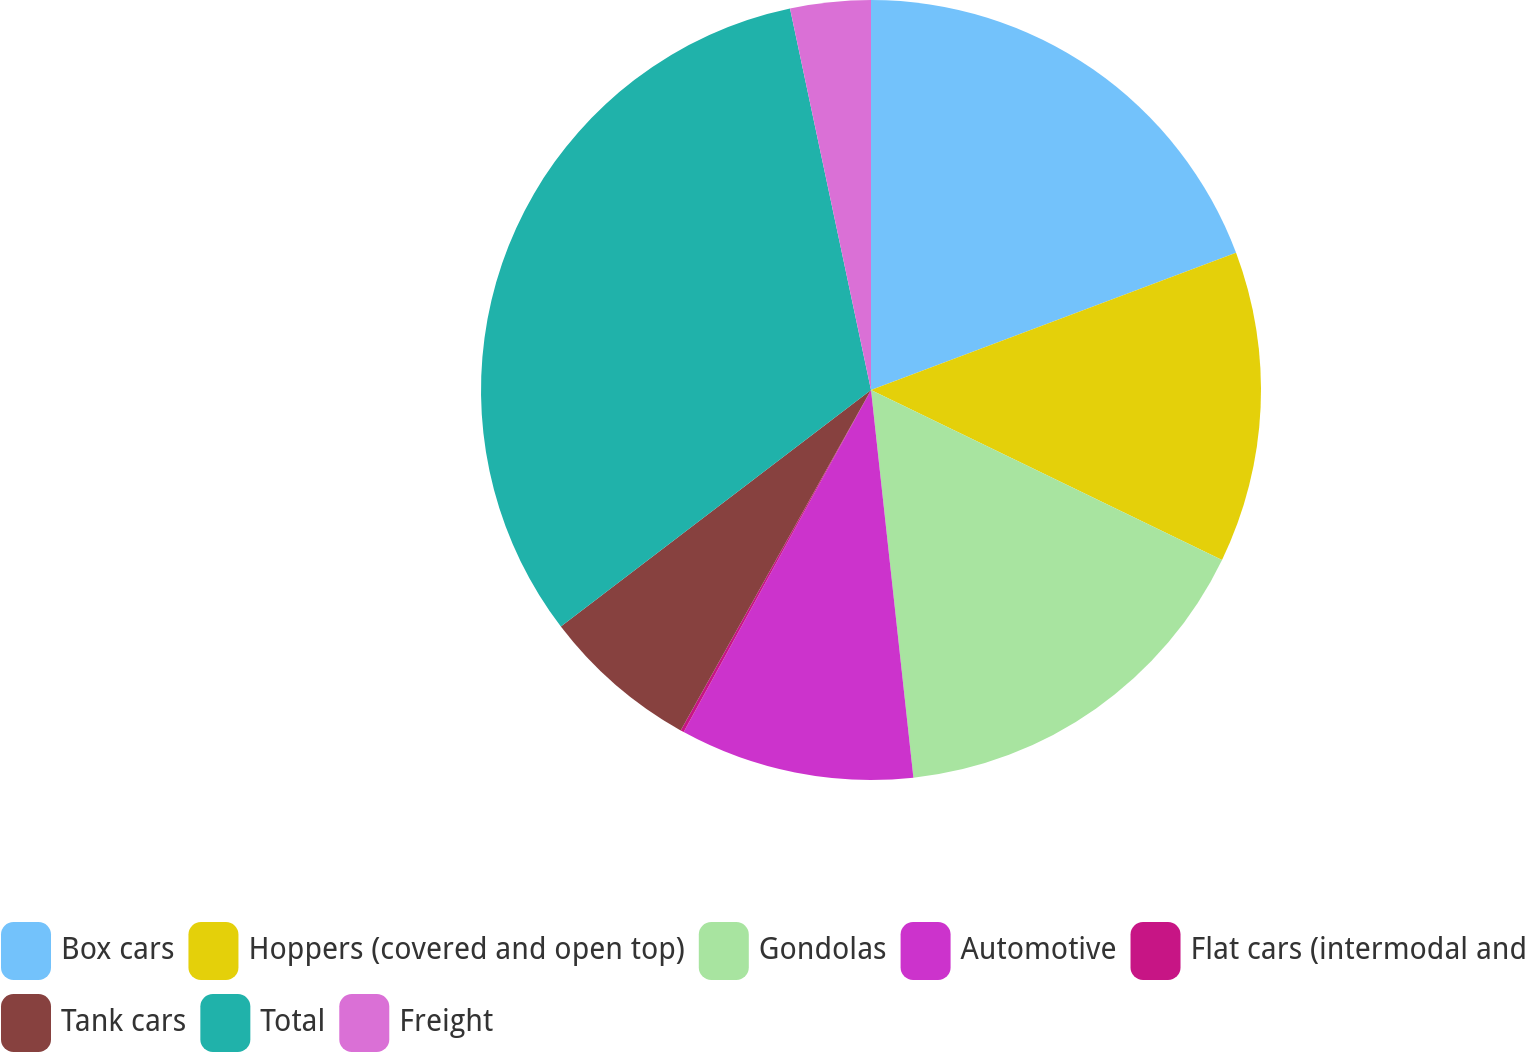Convert chart. <chart><loc_0><loc_0><loc_500><loc_500><pie_chart><fcel>Box cars<fcel>Hoppers (covered and open top)<fcel>Gondolas<fcel>Automotive<fcel>Flat cars (intermodal and<fcel>Tank cars<fcel>Total<fcel>Freight<nl><fcel>19.28%<fcel>12.9%<fcel>16.09%<fcel>9.71%<fcel>0.14%<fcel>6.52%<fcel>32.04%<fcel>3.33%<nl></chart> 